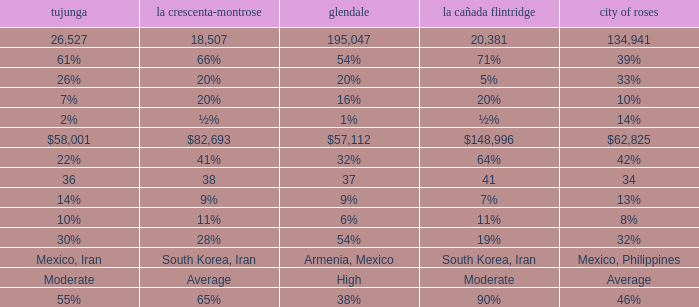What is the figure for Tujunga when Pasadena is 134,941? 26527.0. 